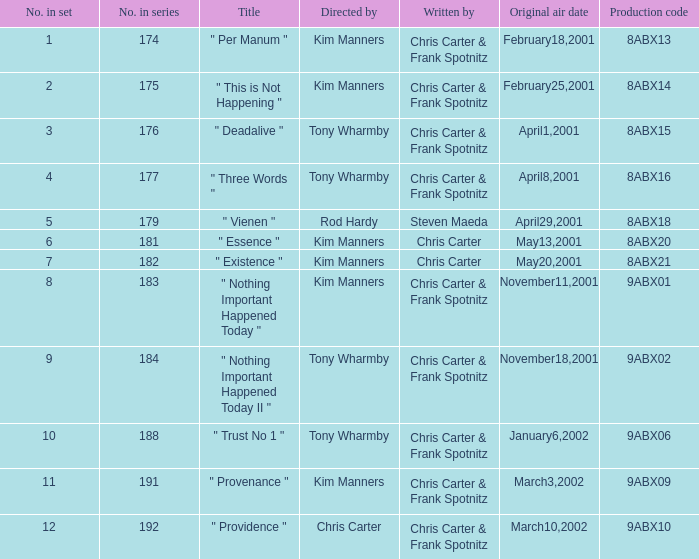What episode number is associated with production code 8abx15? 176.0. 